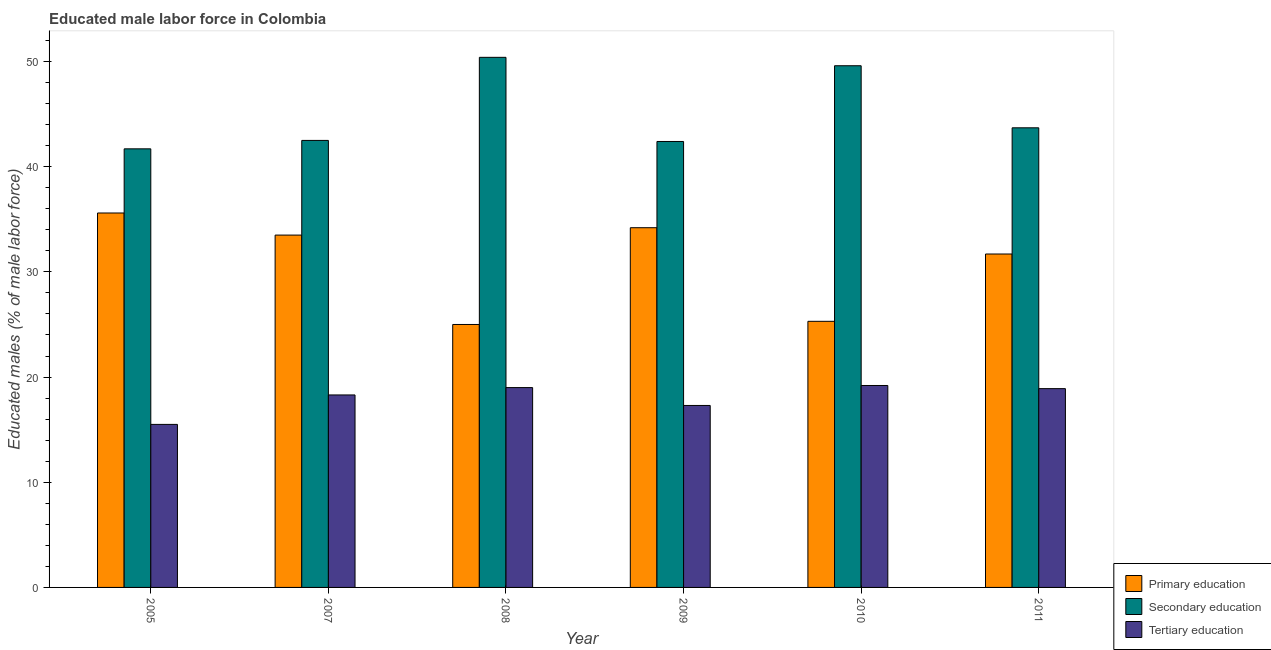Are the number of bars on each tick of the X-axis equal?
Offer a very short reply. Yes. How many bars are there on the 1st tick from the left?
Ensure brevity in your answer.  3. In how many cases, is the number of bars for a given year not equal to the number of legend labels?
Ensure brevity in your answer.  0. What is the percentage of male labor force who received secondary education in 2007?
Offer a very short reply. 42.5. Across all years, what is the maximum percentage of male labor force who received primary education?
Your answer should be very brief. 35.6. Across all years, what is the minimum percentage of male labor force who received primary education?
Offer a terse response. 25. In which year was the percentage of male labor force who received tertiary education minimum?
Provide a short and direct response. 2005. What is the total percentage of male labor force who received secondary education in the graph?
Your response must be concise. 270.3. What is the difference between the percentage of male labor force who received secondary education in 2005 and that in 2011?
Your answer should be very brief. -2. What is the difference between the percentage of male labor force who received tertiary education in 2011 and the percentage of male labor force who received secondary education in 2008?
Your response must be concise. -0.1. What is the average percentage of male labor force who received secondary education per year?
Ensure brevity in your answer.  45.05. What is the ratio of the percentage of male labor force who received primary education in 2008 to that in 2010?
Provide a short and direct response. 0.99. Is the percentage of male labor force who received tertiary education in 2007 less than that in 2011?
Provide a succinct answer. Yes. What is the difference between the highest and the second highest percentage of male labor force who received tertiary education?
Your answer should be very brief. 0.2. What is the difference between the highest and the lowest percentage of male labor force who received primary education?
Offer a very short reply. 10.6. In how many years, is the percentage of male labor force who received secondary education greater than the average percentage of male labor force who received secondary education taken over all years?
Provide a short and direct response. 2. Is the sum of the percentage of male labor force who received tertiary education in 2007 and 2008 greater than the maximum percentage of male labor force who received secondary education across all years?
Your answer should be very brief. Yes. What does the 3rd bar from the right in 2005 represents?
Give a very brief answer. Primary education. How many bars are there?
Keep it short and to the point. 18. Are all the bars in the graph horizontal?
Your response must be concise. No. What is the difference between two consecutive major ticks on the Y-axis?
Your response must be concise. 10. Where does the legend appear in the graph?
Provide a short and direct response. Bottom right. How many legend labels are there?
Offer a very short reply. 3. How are the legend labels stacked?
Your response must be concise. Vertical. What is the title of the graph?
Your answer should be compact. Educated male labor force in Colombia. What is the label or title of the X-axis?
Give a very brief answer. Year. What is the label or title of the Y-axis?
Your answer should be very brief. Educated males (% of male labor force). What is the Educated males (% of male labor force) in Primary education in 2005?
Keep it short and to the point. 35.6. What is the Educated males (% of male labor force) in Secondary education in 2005?
Offer a very short reply. 41.7. What is the Educated males (% of male labor force) of Tertiary education in 2005?
Offer a very short reply. 15.5. What is the Educated males (% of male labor force) of Primary education in 2007?
Provide a succinct answer. 33.5. What is the Educated males (% of male labor force) of Secondary education in 2007?
Make the answer very short. 42.5. What is the Educated males (% of male labor force) of Tertiary education in 2007?
Your answer should be compact. 18.3. What is the Educated males (% of male labor force) in Primary education in 2008?
Provide a succinct answer. 25. What is the Educated males (% of male labor force) of Secondary education in 2008?
Make the answer very short. 50.4. What is the Educated males (% of male labor force) of Primary education in 2009?
Your answer should be compact. 34.2. What is the Educated males (% of male labor force) in Secondary education in 2009?
Offer a terse response. 42.4. What is the Educated males (% of male labor force) of Tertiary education in 2009?
Give a very brief answer. 17.3. What is the Educated males (% of male labor force) of Primary education in 2010?
Offer a terse response. 25.3. What is the Educated males (% of male labor force) in Secondary education in 2010?
Offer a terse response. 49.6. What is the Educated males (% of male labor force) of Tertiary education in 2010?
Your answer should be compact. 19.2. What is the Educated males (% of male labor force) of Primary education in 2011?
Give a very brief answer. 31.7. What is the Educated males (% of male labor force) in Secondary education in 2011?
Offer a terse response. 43.7. What is the Educated males (% of male labor force) in Tertiary education in 2011?
Your answer should be very brief. 18.9. Across all years, what is the maximum Educated males (% of male labor force) of Primary education?
Offer a terse response. 35.6. Across all years, what is the maximum Educated males (% of male labor force) of Secondary education?
Offer a terse response. 50.4. Across all years, what is the maximum Educated males (% of male labor force) in Tertiary education?
Provide a short and direct response. 19.2. Across all years, what is the minimum Educated males (% of male labor force) in Secondary education?
Your answer should be compact. 41.7. What is the total Educated males (% of male labor force) in Primary education in the graph?
Give a very brief answer. 185.3. What is the total Educated males (% of male labor force) of Secondary education in the graph?
Keep it short and to the point. 270.3. What is the total Educated males (% of male labor force) of Tertiary education in the graph?
Provide a succinct answer. 108.2. What is the difference between the Educated males (% of male labor force) of Primary education in 2005 and that in 2007?
Ensure brevity in your answer.  2.1. What is the difference between the Educated males (% of male labor force) in Tertiary education in 2005 and that in 2007?
Offer a very short reply. -2.8. What is the difference between the Educated males (% of male labor force) in Primary education in 2005 and that in 2008?
Provide a succinct answer. 10.6. What is the difference between the Educated males (% of male labor force) of Secondary education in 2005 and that in 2008?
Your response must be concise. -8.7. What is the difference between the Educated males (% of male labor force) in Tertiary education in 2005 and that in 2008?
Offer a very short reply. -3.5. What is the difference between the Educated males (% of male labor force) of Primary education in 2005 and that in 2009?
Keep it short and to the point. 1.4. What is the difference between the Educated males (% of male labor force) of Primary education in 2005 and that in 2010?
Provide a short and direct response. 10.3. What is the difference between the Educated males (% of male labor force) of Secondary education in 2005 and that in 2011?
Make the answer very short. -2. What is the difference between the Educated males (% of male labor force) in Secondary education in 2007 and that in 2008?
Make the answer very short. -7.9. What is the difference between the Educated males (% of male labor force) in Secondary education in 2007 and that in 2009?
Offer a terse response. 0.1. What is the difference between the Educated males (% of male labor force) in Primary education in 2007 and that in 2011?
Your answer should be compact. 1.8. What is the difference between the Educated males (% of male labor force) of Tertiary education in 2007 and that in 2011?
Your answer should be very brief. -0.6. What is the difference between the Educated males (% of male labor force) in Tertiary education in 2008 and that in 2009?
Your response must be concise. 1.7. What is the difference between the Educated males (% of male labor force) in Primary education in 2008 and that in 2010?
Your response must be concise. -0.3. What is the difference between the Educated males (% of male labor force) in Secondary education in 2008 and that in 2010?
Your answer should be very brief. 0.8. What is the difference between the Educated males (% of male labor force) of Tertiary education in 2008 and that in 2010?
Your answer should be compact. -0.2. What is the difference between the Educated males (% of male labor force) in Primary education in 2008 and that in 2011?
Your response must be concise. -6.7. What is the difference between the Educated males (% of male labor force) of Secondary education in 2009 and that in 2010?
Ensure brevity in your answer.  -7.2. What is the difference between the Educated males (% of male labor force) in Tertiary education in 2009 and that in 2011?
Provide a succinct answer. -1.6. What is the difference between the Educated males (% of male labor force) in Primary education in 2010 and that in 2011?
Ensure brevity in your answer.  -6.4. What is the difference between the Educated males (% of male labor force) in Tertiary education in 2010 and that in 2011?
Provide a succinct answer. 0.3. What is the difference between the Educated males (% of male labor force) of Primary education in 2005 and the Educated males (% of male labor force) of Secondary education in 2007?
Provide a succinct answer. -6.9. What is the difference between the Educated males (% of male labor force) of Primary education in 2005 and the Educated males (% of male labor force) of Tertiary education in 2007?
Your response must be concise. 17.3. What is the difference between the Educated males (% of male labor force) of Secondary education in 2005 and the Educated males (% of male labor force) of Tertiary education in 2007?
Provide a succinct answer. 23.4. What is the difference between the Educated males (% of male labor force) of Primary education in 2005 and the Educated males (% of male labor force) of Secondary education in 2008?
Offer a very short reply. -14.8. What is the difference between the Educated males (% of male labor force) in Primary education in 2005 and the Educated males (% of male labor force) in Tertiary education in 2008?
Give a very brief answer. 16.6. What is the difference between the Educated males (% of male labor force) of Secondary education in 2005 and the Educated males (% of male labor force) of Tertiary education in 2008?
Your answer should be compact. 22.7. What is the difference between the Educated males (% of male labor force) in Primary education in 2005 and the Educated males (% of male labor force) in Secondary education in 2009?
Keep it short and to the point. -6.8. What is the difference between the Educated males (% of male labor force) of Primary education in 2005 and the Educated males (% of male labor force) of Tertiary education in 2009?
Keep it short and to the point. 18.3. What is the difference between the Educated males (% of male labor force) of Secondary education in 2005 and the Educated males (% of male labor force) of Tertiary education in 2009?
Your answer should be very brief. 24.4. What is the difference between the Educated males (% of male labor force) of Primary education in 2005 and the Educated males (% of male labor force) of Tertiary education in 2010?
Offer a very short reply. 16.4. What is the difference between the Educated males (% of male labor force) of Secondary education in 2005 and the Educated males (% of male labor force) of Tertiary education in 2010?
Your response must be concise. 22.5. What is the difference between the Educated males (% of male labor force) in Primary education in 2005 and the Educated males (% of male labor force) in Tertiary education in 2011?
Your response must be concise. 16.7. What is the difference between the Educated males (% of male labor force) of Secondary education in 2005 and the Educated males (% of male labor force) of Tertiary education in 2011?
Your answer should be very brief. 22.8. What is the difference between the Educated males (% of male labor force) of Primary education in 2007 and the Educated males (% of male labor force) of Secondary education in 2008?
Provide a short and direct response. -16.9. What is the difference between the Educated males (% of male labor force) of Primary education in 2007 and the Educated males (% of male labor force) of Secondary education in 2009?
Offer a terse response. -8.9. What is the difference between the Educated males (% of male labor force) of Secondary education in 2007 and the Educated males (% of male labor force) of Tertiary education in 2009?
Make the answer very short. 25.2. What is the difference between the Educated males (% of male labor force) of Primary education in 2007 and the Educated males (% of male labor force) of Secondary education in 2010?
Keep it short and to the point. -16.1. What is the difference between the Educated males (% of male labor force) in Primary education in 2007 and the Educated males (% of male labor force) in Tertiary education in 2010?
Give a very brief answer. 14.3. What is the difference between the Educated males (% of male labor force) in Secondary education in 2007 and the Educated males (% of male labor force) in Tertiary education in 2010?
Provide a short and direct response. 23.3. What is the difference between the Educated males (% of male labor force) of Secondary education in 2007 and the Educated males (% of male labor force) of Tertiary education in 2011?
Your answer should be very brief. 23.6. What is the difference between the Educated males (% of male labor force) of Primary education in 2008 and the Educated males (% of male labor force) of Secondary education in 2009?
Your answer should be very brief. -17.4. What is the difference between the Educated males (% of male labor force) of Primary education in 2008 and the Educated males (% of male labor force) of Tertiary education in 2009?
Your answer should be compact. 7.7. What is the difference between the Educated males (% of male labor force) of Secondary education in 2008 and the Educated males (% of male labor force) of Tertiary education in 2009?
Give a very brief answer. 33.1. What is the difference between the Educated males (% of male labor force) in Primary education in 2008 and the Educated males (% of male labor force) in Secondary education in 2010?
Ensure brevity in your answer.  -24.6. What is the difference between the Educated males (% of male labor force) of Secondary education in 2008 and the Educated males (% of male labor force) of Tertiary education in 2010?
Your response must be concise. 31.2. What is the difference between the Educated males (% of male labor force) in Primary education in 2008 and the Educated males (% of male labor force) in Secondary education in 2011?
Offer a very short reply. -18.7. What is the difference between the Educated males (% of male labor force) of Secondary education in 2008 and the Educated males (% of male labor force) of Tertiary education in 2011?
Provide a succinct answer. 31.5. What is the difference between the Educated males (% of male labor force) in Primary education in 2009 and the Educated males (% of male labor force) in Secondary education in 2010?
Provide a short and direct response. -15.4. What is the difference between the Educated males (% of male labor force) of Secondary education in 2009 and the Educated males (% of male labor force) of Tertiary education in 2010?
Provide a succinct answer. 23.2. What is the difference between the Educated males (% of male labor force) in Secondary education in 2009 and the Educated males (% of male labor force) in Tertiary education in 2011?
Ensure brevity in your answer.  23.5. What is the difference between the Educated males (% of male labor force) of Primary education in 2010 and the Educated males (% of male labor force) of Secondary education in 2011?
Offer a very short reply. -18.4. What is the difference between the Educated males (% of male labor force) in Primary education in 2010 and the Educated males (% of male labor force) in Tertiary education in 2011?
Provide a short and direct response. 6.4. What is the difference between the Educated males (% of male labor force) in Secondary education in 2010 and the Educated males (% of male labor force) in Tertiary education in 2011?
Offer a very short reply. 30.7. What is the average Educated males (% of male labor force) in Primary education per year?
Your answer should be very brief. 30.88. What is the average Educated males (% of male labor force) in Secondary education per year?
Provide a succinct answer. 45.05. What is the average Educated males (% of male labor force) in Tertiary education per year?
Your answer should be very brief. 18.03. In the year 2005, what is the difference between the Educated males (% of male labor force) in Primary education and Educated males (% of male labor force) in Secondary education?
Your answer should be very brief. -6.1. In the year 2005, what is the difference between the Educated males (% of male labor force) of Primary education and Educated males (% of male labor force) of Tertiary education?
Keep it short and to the point. 20.1. In the year 2005, what is the difference between the Educated males (% of male labor force) of Secondary education and Educated males (% of male labor force) of Tertiary education?
Provide a short and direct response. 26.2. In the year 2007, what is the difference between the Educated males (% of male labor force) in Primary education and Educated males (% of male labor force) in Secondary education?
Give a very brief answer. -9. In the year 2007, what is the difference between the Educated males (% of male labor force) of Primary education and Educated males (% of male labor force) of Tertiary education?
Keep it short and to the point. 15.2. In the year 2007, what is the difference between the Educated males (% of male labor force) in Secondary education and Educated males (% of male labor force) in Tertiary education?
Offer a very short reply. 24.2. In the year 2008, what is the difference between the Educated males (% of male labor force) of Primary education and Educated males (% of male labor force) of Secondary education?
Offer a very short reply. -25.4. In the year 2008, what is the difference between the Educated males (% of male labor force) in Secondary education and Educated males (% of male labor force) in Tertiary education?
Ensure brevity in your answer.  31.4. In the year 2009, what is the difference between the Educated males (% of male labor force) of Secondary education and Educated males (% of male labor force) of Tertiary education?
Provide a short and direct response. 25.1. In the year 2010, what is the difference between the Educated males (% of male labor force) in Primary education and Educated males (% of male labor force) in Secondary education?
Provide a succinct answer. -24.3. In the year 2010, what is the difference between the Educated males (% of male labor force) of Primary education and Educated males (% of male labor force) of Tertiary education?
Your answer should be compact. 6.1. In the year 2010, what is the difference between the Educated males (% of male labor force) of Secondary education and Educated males (% of male labor force) of Tertiary education?
Give a very brief answer. 30.4. In the year 2011, what is the difference between the Educated males (% of male labor force) of Primary education and Educated males (% of male labor force) of Secondary education?
Give a very brief answer. -12. In the year 2011, what is the difference between the Educated males (% of male labor force) of Secondary education and Educated males (% of male labor force) of Tertiary education?
Your response must be concise. 24.8. What is the ratio of the Educated males (% of male labor force) in Primary education in 2005 to that in 2007?
Give a very brief answer. 1.06. What is the ratio of the Educated males (% of male labor force) in Secondary education in 2005 to that in 2007?
Give a very brief answer. 0.98. What is the ratio of the Educated males (% of male labor force) in Tertiary education in 2005 to that in 2007?
Provide a short and direct response. 0.85. What is the ratio of the Educated males (% of male labor force) of Primary education in 2005 to that in 2008?
Make the answer very short. 1.42. What is the ratio of the Educated males (% of male labor force) of Secondary education in 2005 to that in 2008?
Provide a succinct answer. 0.83. What is the ratio of the Educated males (% of male labor force) in Tertiary education in 2005 to that in 2008?
Provide a short and direct response. 0.82. What is the ratio of the Educated males (% of male labor force) of Primary education in 2005 to that in 2009?
Give a very brief answer. 1.04. What is the ratio of the Educated males (% of male labor force) of Secondary education in 2005 to that in 2009?
Your response must be concise. 0.98. What is the ratio of the Educated males (% of male labor force) in Tertiary education in 2005 to that in 2009?
Provide a succinct answer. 0.9. What is the ratio of the Educated males (% of male labor force) in Primary education in 2005 to that in 2010?
Ensure brevity in your answer.  1.41. What is the ratio of the Educated males (% of male labor force) in Secondary education in 2005 to that in 2010?
Offer a terse response. 0.84. What is the ratio of the Educated males (% of male labor force) in Tertiary education in 2005 to that in 2010?
Provide a succinct answer. 0.81. What is the ratio of the Educated males (% of male labor force) of Primary education in 2005 to that in 2011?
Your response must be concise. 1.12. What is the ratio of the Educated males (% of male labor force) in Secondary education in 2005 to that in 2011?
Offer a very short reply. 0.95. What is the ratio of the Educated males (% of male labor force) of Tertiary education in 2005 to that in 2011?
Provide a succinct answer. 0.82. What is the ratio of the Educated males (% of male labor force) of Primary education in 2007 to that in 2008?
Your answer should be compact. 1.34. What is the ratio of the Educated males (% of male labor force) of Secondary education in 2007 to that in 2008?
Keep it short and to the point. 0.84. What is the ratio of the Educated males (% of male labor force) in Tertiary education in 2007 to that in 2008?
Make the answer very short. 0.96. What is the ratio of the Educated males (% of male labor force) of Primary education in 2007 to that in 2009?
Offer a very short reply. 0.98. What is the ratio of the Educated males (% of male labor force) in Tertiary education in 2007 to that in 2009?
Your response must be concise. 1.06. What is the ratio of the Educated males (% of male labor force) in Primary education in 2007 to that in 2010?
Keep it short and to the point. 1.32. What is the ratio of the Educated males (% of male labor force) of Secondary education in 2007 to that in 2010?
Give a very brief answer. 0.86. What is the ratio of the Educated males (% of male labor force) in Tertiary education in 2007 to that in 2010?
Your answer should be compact. 0.95. What is the ratio of the Educated males (% of male labor force) in Primary education in 2007 to that in 2011?
Provide a short and direct response. 1.06. What is the ratio of the Educated males (% of male labor force) in Secondary education in 2007 to that in 2011?
Keep it short and to the point. 0.97. What is the ratio of the Educated males (% of male labor force) in Tertiary education in 2007 to that in 2011?
Ensure brevity in your answer.  0.97. What is the ratio of the Educated males (% of male labor force) of Primary education in 2008 to that in 2009?
Keep it short and to the point. 0.73. What is the ratio of the Educated males (% of male labor force) in Secondary education in 2008 to that in 2009?
Offer a very short reply. 1.19. What is the ratio of the Educated males (% of male labor force) of Tertiary education in 2008 to that in 2009?
Keep it short and to the point. 1.1. What is the ratio of the Educated males (% of male labor force) of Primary education in 2008 to that in 2010?
Your answer should be compact. 0.99. What is the ratio of the Educated males (% of male labor force) in Secondary education in 2008 to that in 2010?
Give a very brief answer. 1.02. What is the ratio of the Educated males (% of male labor force) of Tertiary education in 2008 to that in 2010?
Give a very brief answer. 0.99. What is the ratio of the Educated males (% of male labor force) in Primary education in 2008 to that in 2011?
Your answer should be compact. 0.79. What is the ratio of the Educated males (% of male labor force) of Secondary education in 2008 to that in 2011?
Provide a succinct answer. 1.15. What is the ratio of the Educated males (% of male labor force) of Primary education in 2009 to that in 2010?
Keep it short and to the point. 1.35. What is the ratio of the Educated males (% of male labor force) of Secondary education in 2009 to that in 2010?
Offer a terse response. 0.85. What is the ratio of the Educated males (% of male labor force) in Tertiary education in 2009 to that in 2010?
Your answer should be compact. 0.9. What is the ratio of the Educated males (% of male labor force) of Primary education in 2009 to that in 2011?
Your response must be concise. 1.08. What is the ratio of the Educated males (% of male labor force) in Secondary education in 2009 to that in 2011?
Your response must be concise. 0.97. What is the ratio of the Educated males (% of male labor force) of Tertiary education in 2009 to that in 2011?
Keep it short and to the point. 0.92. What is the ratio of the Educated males (% of male labor force) in Primary education in 2010 to that in 2011?
Provide a succinct answer. 0.8. What is the ratio of the Educated males (% of male labor force) in Secondary education in 2010 to that in 2011?
Ensure brevity in your answer.  1.14. What is the ratio of the Educated males (% of male labor force) in Tertiary education in 2010 to that in 2011?
Make the answer very short. 1.02. What is the difference between the highest and the second highest Educated males (% of male labor force) of Primary education?
Provide a succinct answer. 1.4. What is the difference between the highest and the second highest Educated males (% of male labor force) in Secondary education?
Provide a succinct answer. 0.8. What is the difference between the highest and the lowest Educated males (% of male labor force) of Primary education?
Make the answer very short. 10.6. 